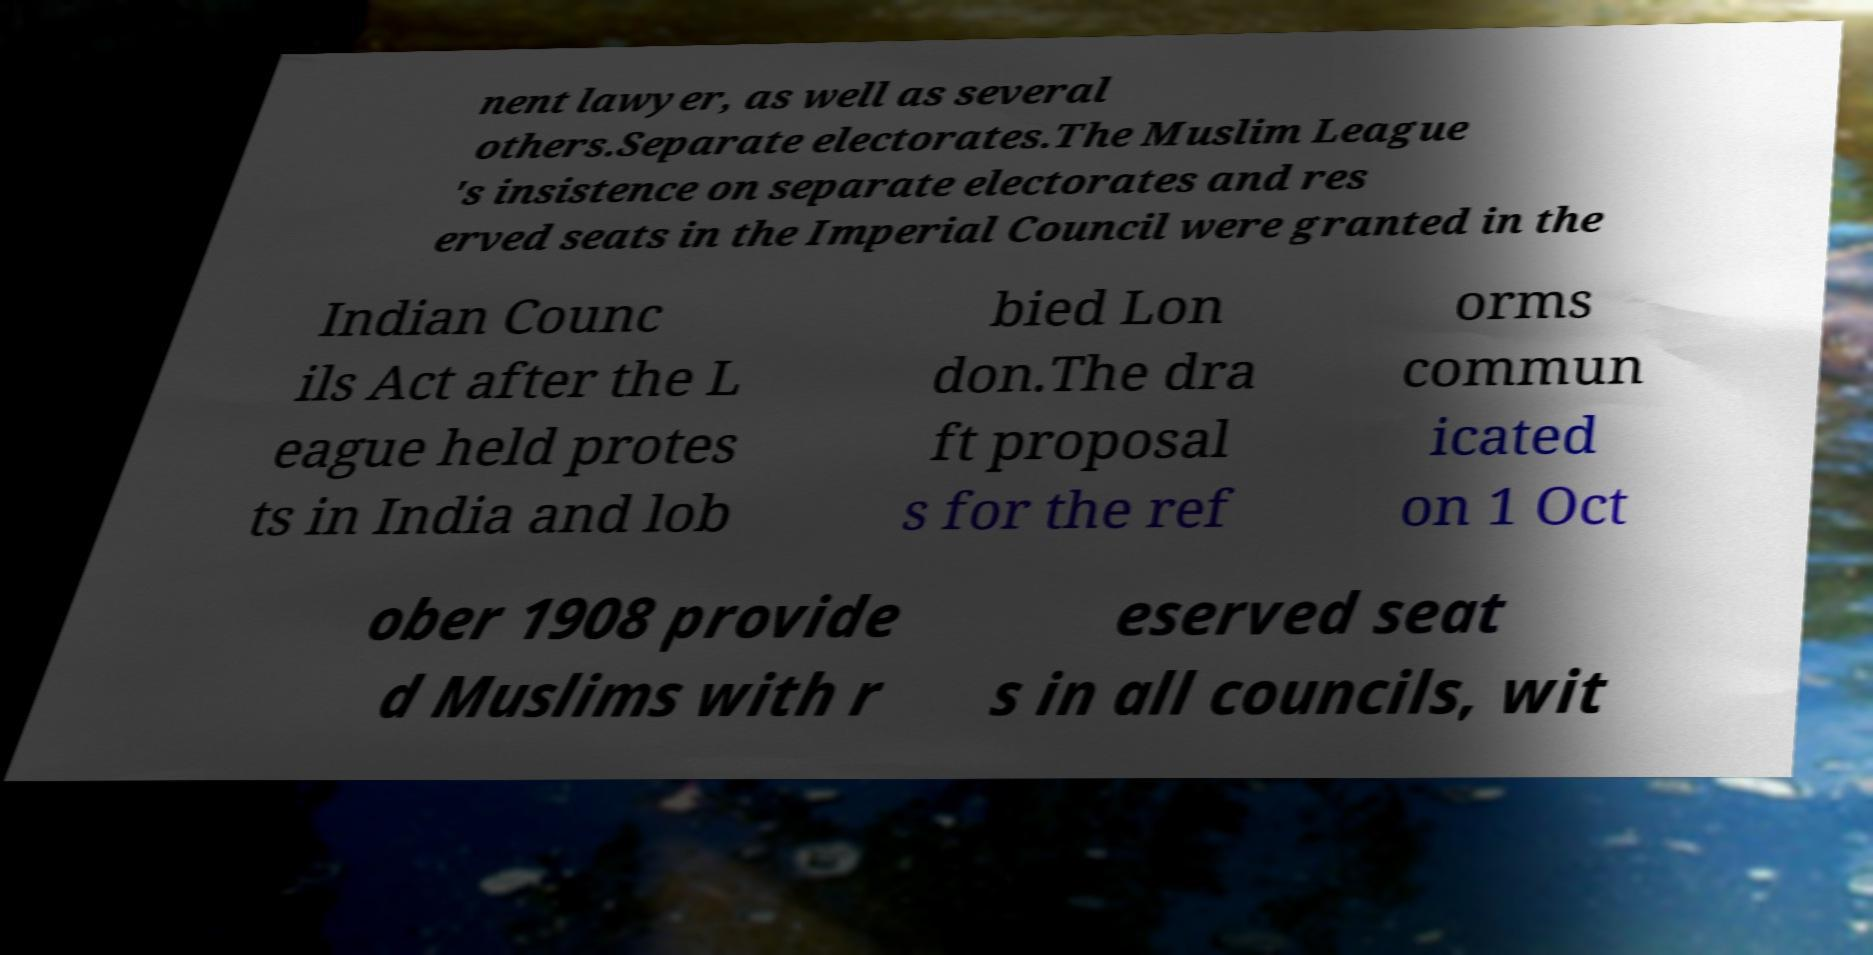Can you read and provide the text displayed in the image?This photo seems to have some interesting text. Can you extract and type it out for me? nent lawyer, as well as several others.Separate electorates.The Muslim League 's insistence on separate electorates and res erved seats in the Imperial Council were granted in the Indian Counc ils Act after the L eague held protes ts in India and lob bied Lon don.The dra ft proposal s for the ref orms commun icated on 1 Oct ober 1908 provide d Muslims with r eserved seat s in all councils, wit 